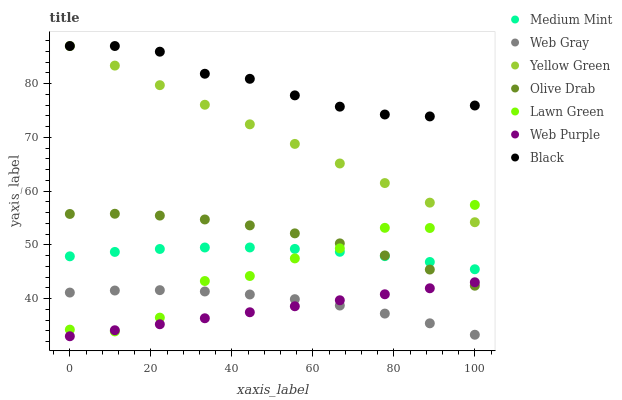Does Web Purple have the minimum area under the curve?
Answer yes or no. Yes. Does Black have the maximum area under the curve?
Answer yes or no. Yes. Does Lawn Green have the minimum area under the curve?
Answer yes or no. No. Does Lawn Green have the maximum area under the curve?
Answer yes or no. No. Is Yellow Green the smoothest?
Answer yes or no. Yes. Is Lawn Green the roughest?
Answer yes or no. Yes. Is Web Gray the smoothest?
Answer yes or no. No. Is Web Gray the roughest?
Answer yes or no. No. Does Web Purple have the lowest value?
Answer yes or no. Yes. Does Lawn Green have the lowest value?
Answer yes or no. No. Does Black have the highest value?
Answer yes or no. Yes. Does Lawn Green have the highest value?
Answer yes or no. No. Is Olive Drab less than Yellow Green?
Answer yes or no. Yes. Is Black greater than Web Gray?
Answer yes or no. Yes. Does Web Purple intersect Lawn Green?
Answer yes or no. Yes. Is Web Purple less than Lawn Green?
Answer yes or no. No. Is Web Purple greater than Lawn Green?
Answer yes or no. No. Does Olive Drab intersect Yellow Green?
Answer yes or no. No. 